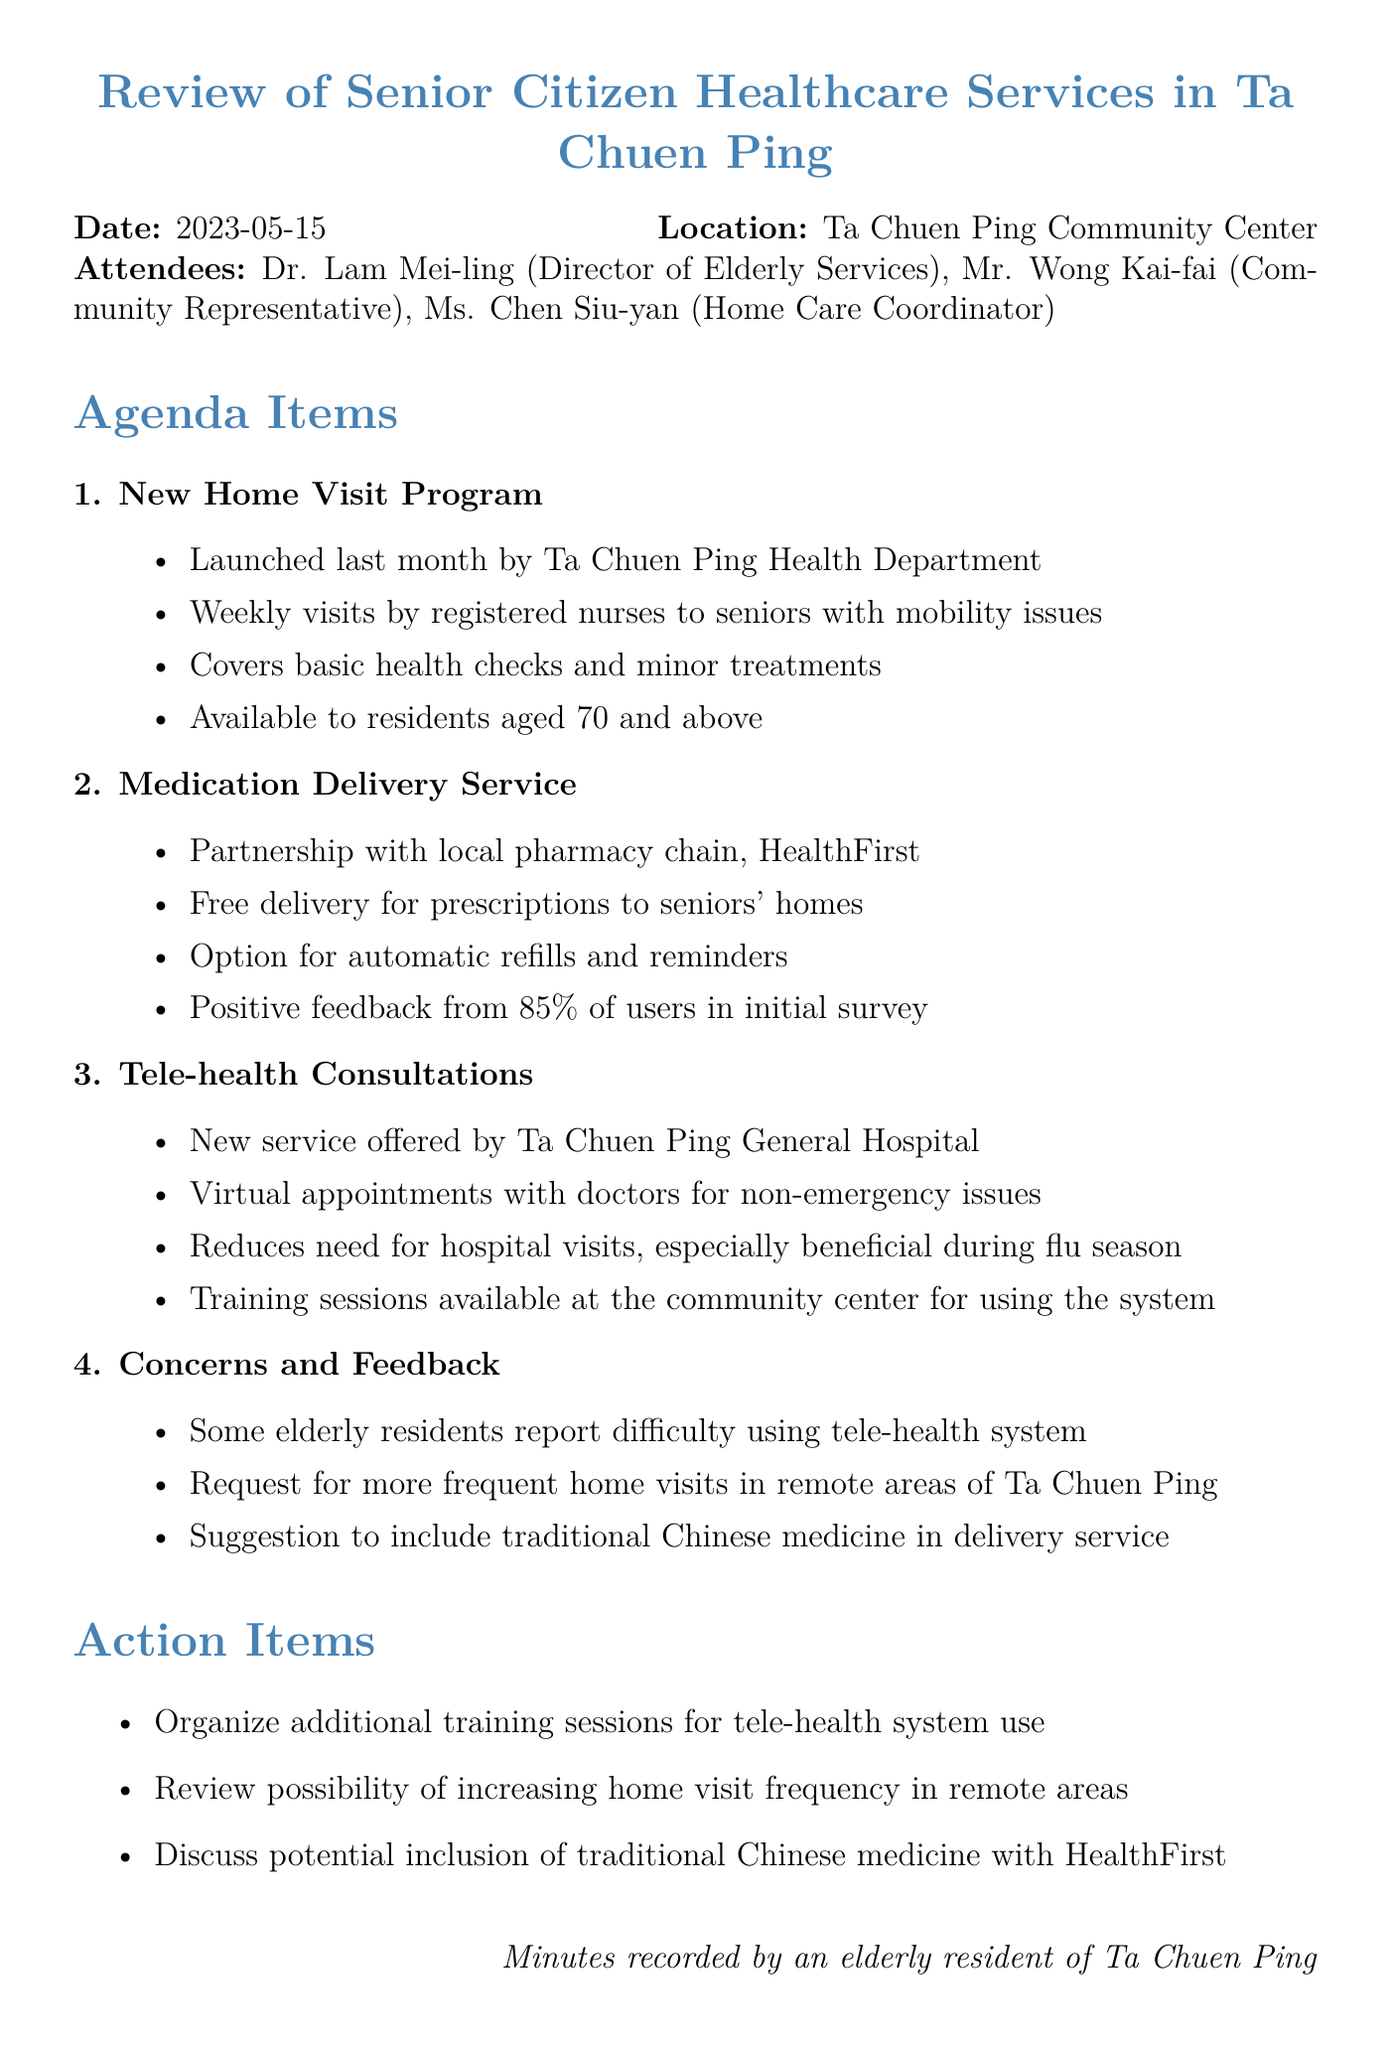What was the date of the meeting? The date of the meeting is mentioned clearly at the beginning of the document.
Answer: 2023-05-15 Who is the director of elderly services? This information is provided in the list of attendees, which includes the roles of each person.
Answer: Dr. Lam Mei-ling How often do nurses visit seniors in the home visit program? The document specifies the frequency of visits in the details of the home visit program.
Answer: Weekly What percentage of users provided positive feedback for the medication delivery service? The feedback percentage is stated directly in the details of the medication delivery service.
Answer: 85% What is one of the concerns raised by elderly residents? This is found in the concerns and feedback section of the document.
Answer: Difficulty using tele-health system How many action items are noted in the document? The number of action items listed is calculated by counting them in the action items section.
Answer: Three Which pharmacy is partnered for the medication delivery service? This information is located in the details of the medication delivery service.
Answer: HealthFirst What suggestion was made regarding traditional Chinese medicine? The suggestion is included in the concerns and feedback section of the meeting minutes.
Answer: Inclusion in delivery service 